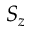<formula> <loc_0><loc_0><loc_500><loc_500>S _ { z }</formula> 